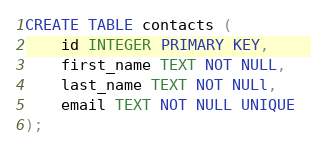<code> <loc_0><loc_0><loc_500><loc_500><_SQL_>CREATE TABLE contacts (
    id INTEGER PRIMARY KEY,
    first_name TEXT NOT NULL,
    last_name TEXT NOT NULl,
    email TEXT NOT NULL UNIQUE
);</code> 